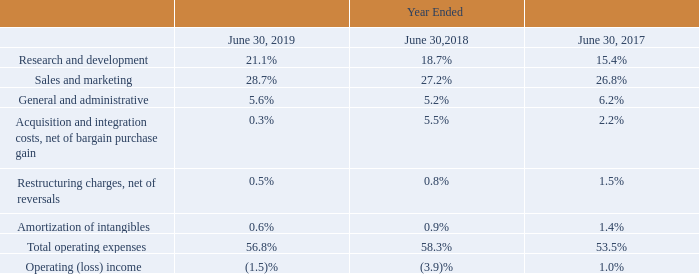Operating Expenses
The following table highlights our operating expenses and operating loss as a percentage of net revenues:
Which years does the table provide information for the company's operating expenses and operating loss as a percentage of net revenues? 2019, 2018, 2017. What was Research and Development as a percentage of net revenues in 2018?
Answer scale should be: percent. 18.7. What was Sales and Marketing as a percentage of net revenues in 2019?
Answer scale should be: percent. 28.7. How many years did Sales and Marketing as a percentage of net revenues exceed 20%? 2019##2018##2017
Answer: 3. Which years did General and administrative as a percentage of net revenues exceed 6%? (2017:6.2)
Answer: 2017. What was the change in the Total operating expenses as a percentage of net revenues between 2018 and 2019?
Answer scale should be: percent. 56.8-58.3
Answer: -1.5. 